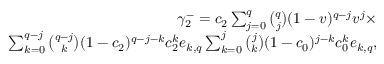<formula> <loc_0><loc_0><loc_500><loc_500>\begin{array} { r } { \gamma _ { 2 } ^ { - } = c _ { 2 } \sum _ { j = 0 } ^ { q } { \binom { q } { j } } ( 1 - v ) ^ { q - j } v ^ { j } \times } \\ { \sum _ { k = 0 } ^ { q - j } { \binom { q - j } { k } } ( 1 - c _ { 2 } ) ^ { q - j - k } c _ { 2 } ^ { k } e _ { k , q } \sum _ { k = 0 } ^ { j } { \binom { j } { k } } ( 1 - c _ { 0 } ) ^ { j - k } c _ { 0 } ^ { k } e _ { k , q } , } \end{array}</formula> 